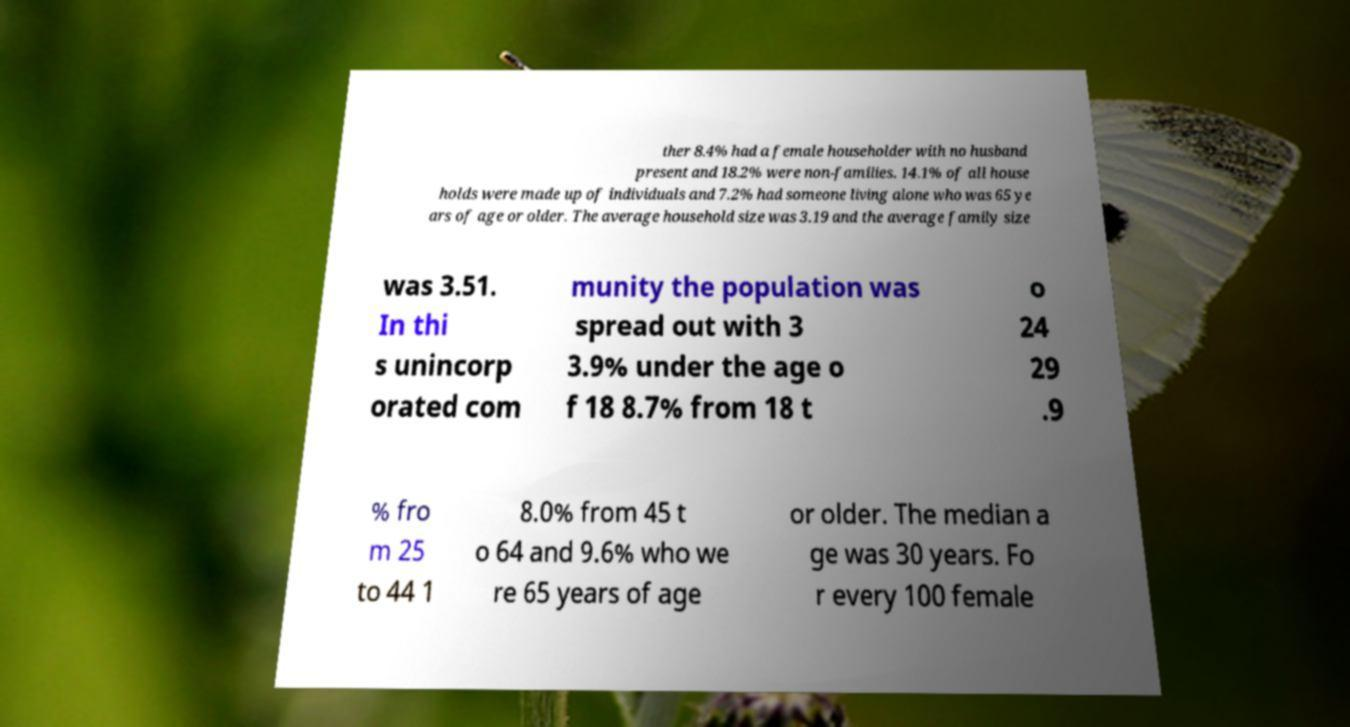For documentation purposes, I need the text within this image transcribed. Could you provide that? ther 8.4% had a female householder with no husband present and 18.2% were non-families. 14.1% of all house holds were made up of individuals and 7.2% had someone living alone who was 65 ye ars of age or older. The average household size was 3.19 and the average family size was 3.51. In thi s unincorp orated com munity the population was spread out with 3 3.9% under the age o f 18 8.7% from 18 t o 24 29 .9 % fro m 25 to 44 1 8.0% from 45 t o 64 and 9.6% who we re 65 years of age or older. The median a ge was 30 years. Fo r every 100 female 